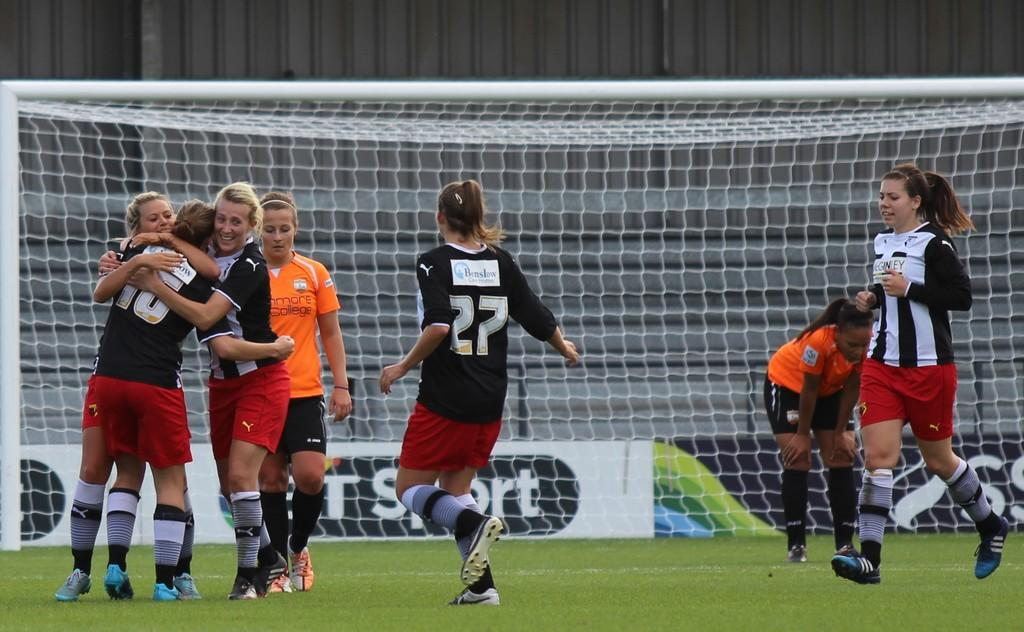<image>
Describe the image concisely. 27 runs to her teammates to celebrate their win. 